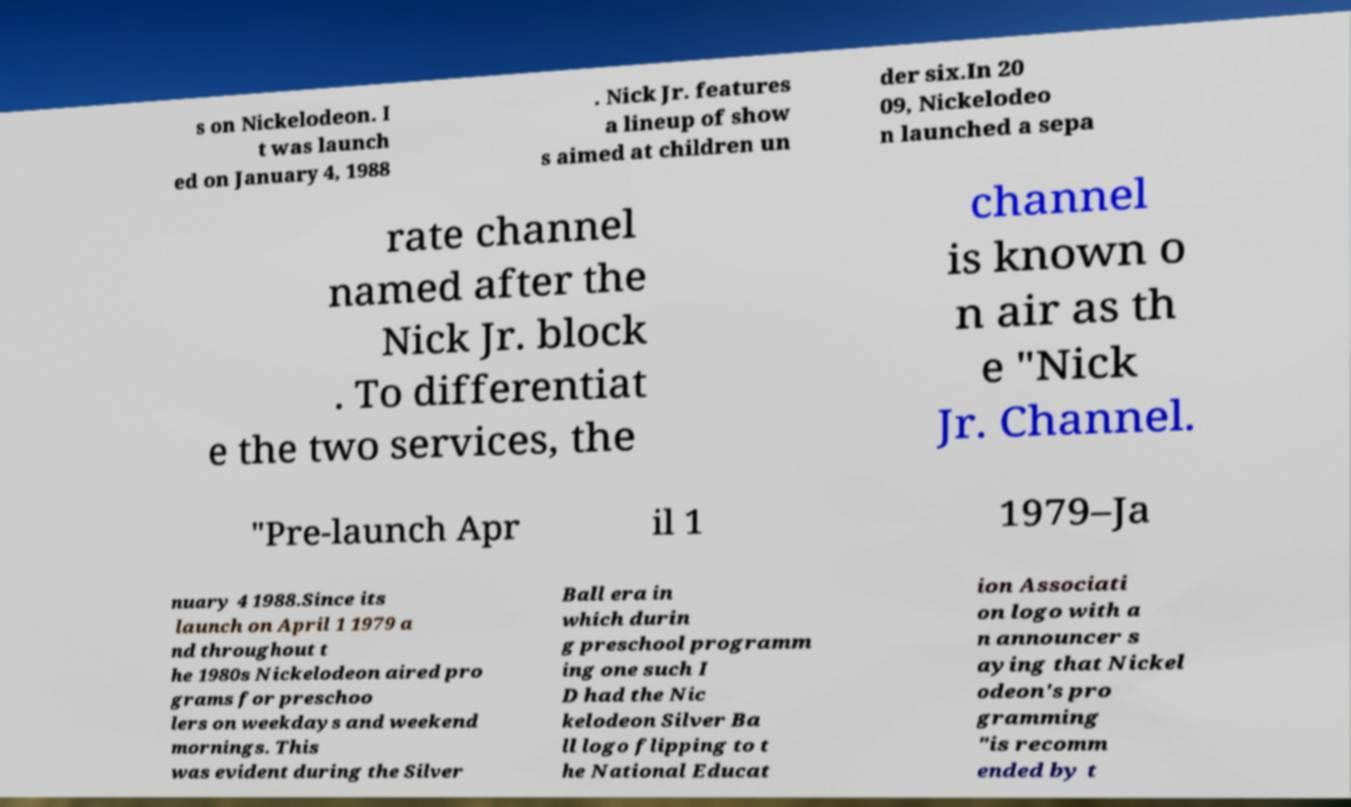Could you extract and type out the text from this image? s on Nickelodeon. I t was launch ed on January 4, 1988 . Nick Jr. features a lineup of show s aimed at children un der six.In 20 09, Nickelodeo n launched a sepa rate channel named after the Nick Jr. block . To differentiat e the two services, the channel is known o n air as th e "Nick Jr. Channel. "Pre-launch Apr il 1 1979–Ja nuary 4 1988.Since its launch on April 1 1979 a nd throughout t he 1980s Nickelodeon aired pro grams for preschoo lers on weekdays and weekend mornings. This was evident during the Silver Ball era in which durin g preschool programm ing one such I D had the Nic kelodeon Silver Ba ll logo flipping to t he National Educat ion Associati on logo with a n announcer s aying that Nickel odeon's pro gramming "is recomm ended by t 